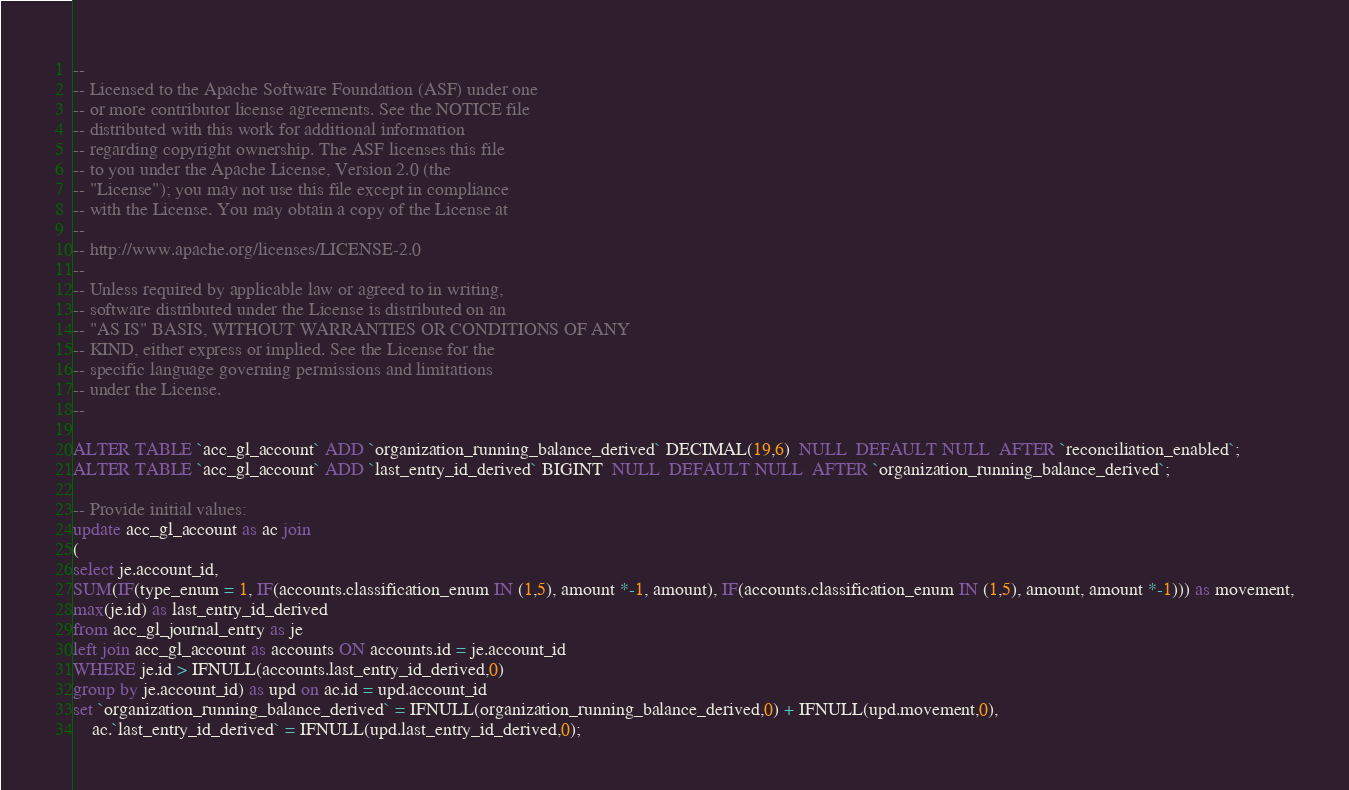Convert code to text. <code><loc_0><loc_0><loc_500><loc_500><_SQL_>--
-- Licensed to the Apache Software Foundation (ASF) under one
-- or more contributor license agreements. See the NOTICE file
-- distributed with this work for additional information
-- regarding copyright ownership. The ASF licenses this file
-- to you under the Apache License, Version 2.0 (the
-- "License"); you may not use this file except in compliance
-- with the License. You may obtain a copy of the License at
--
-- http://www.apache.org/licenses/LICENSE-2.0
--
-- Unless required by applicable law or agreed to in writing,
-- software distributed under the License is distributed on an
-- "AS IS" BASIS, WITHOUT WARRANTIES OR CONDITIONS OF ANY
-- KIND, either express or implied. See the License for the
-- specific language governing permissions and limitations
-- under the License.
--

ALTER TABLE `acc_gl_account` ADD `organization_running_balance_derived` DECIMAL(19,6)  NULL  DEFAULT NULL  AFTER `reconciliation_enabled`;
ALTER TABLE `acc_gl_account` ADD `last_entry_id_derived` BIGINT  NULL  DEFAULT NULL  AFTER `organization_running_balance_derived`;

-- Provide initial values:
update acc_gl_account as ac join
(
select je.account_id,
SUM(IF(type_enum = 1, IF(accounts.classification_enum IN (1,5), amount *-1, amount), IF(accounts.classification_enum IN (1,5), amount, amount *-1))) as movement,
max(je.id) as last_entry_id_derived
from acc_gl_journal_entry as je
left join acc_gl_account as accounts ON accounts.id = je.account_id
WHERE je.id > IFNULL(accounts.last_entry_id_derived,0)
group by je.account_id) as upd on ac.id = upd.account_id
set `organization_running_balance_derived` = IFNULL(organization_running_balance_derived,0) + IFNULL(upd.movement,0),
	ac.`last_entry_id_derived` = IFNULL(upd.last_entry_id_derived,0);</code> 